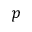Convert formula to latex. <formula><loc_0><loc_0><loc_500><loc_500>p</formula> 